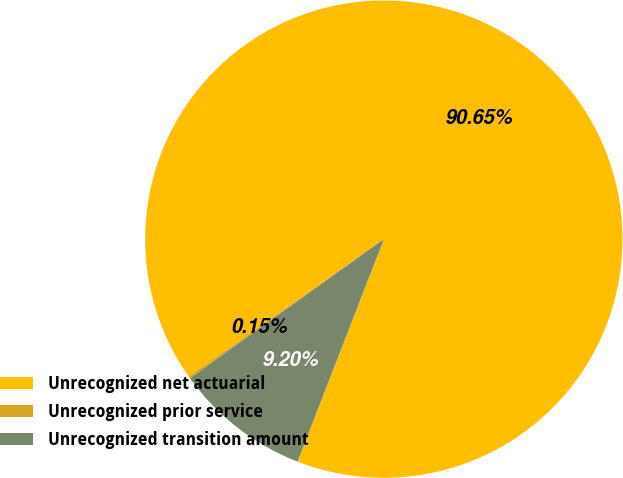<chart> <loc_0><loc_0><loc_500><loc_500><pie_chart><fcel>Unrecognized net actuarial<fcel>Unrecognized prior service<fcel>Unrecognized transition amount<nl><fcel>90.65%<fcel>0.15%<fcel>9.2%<nl></chart> 